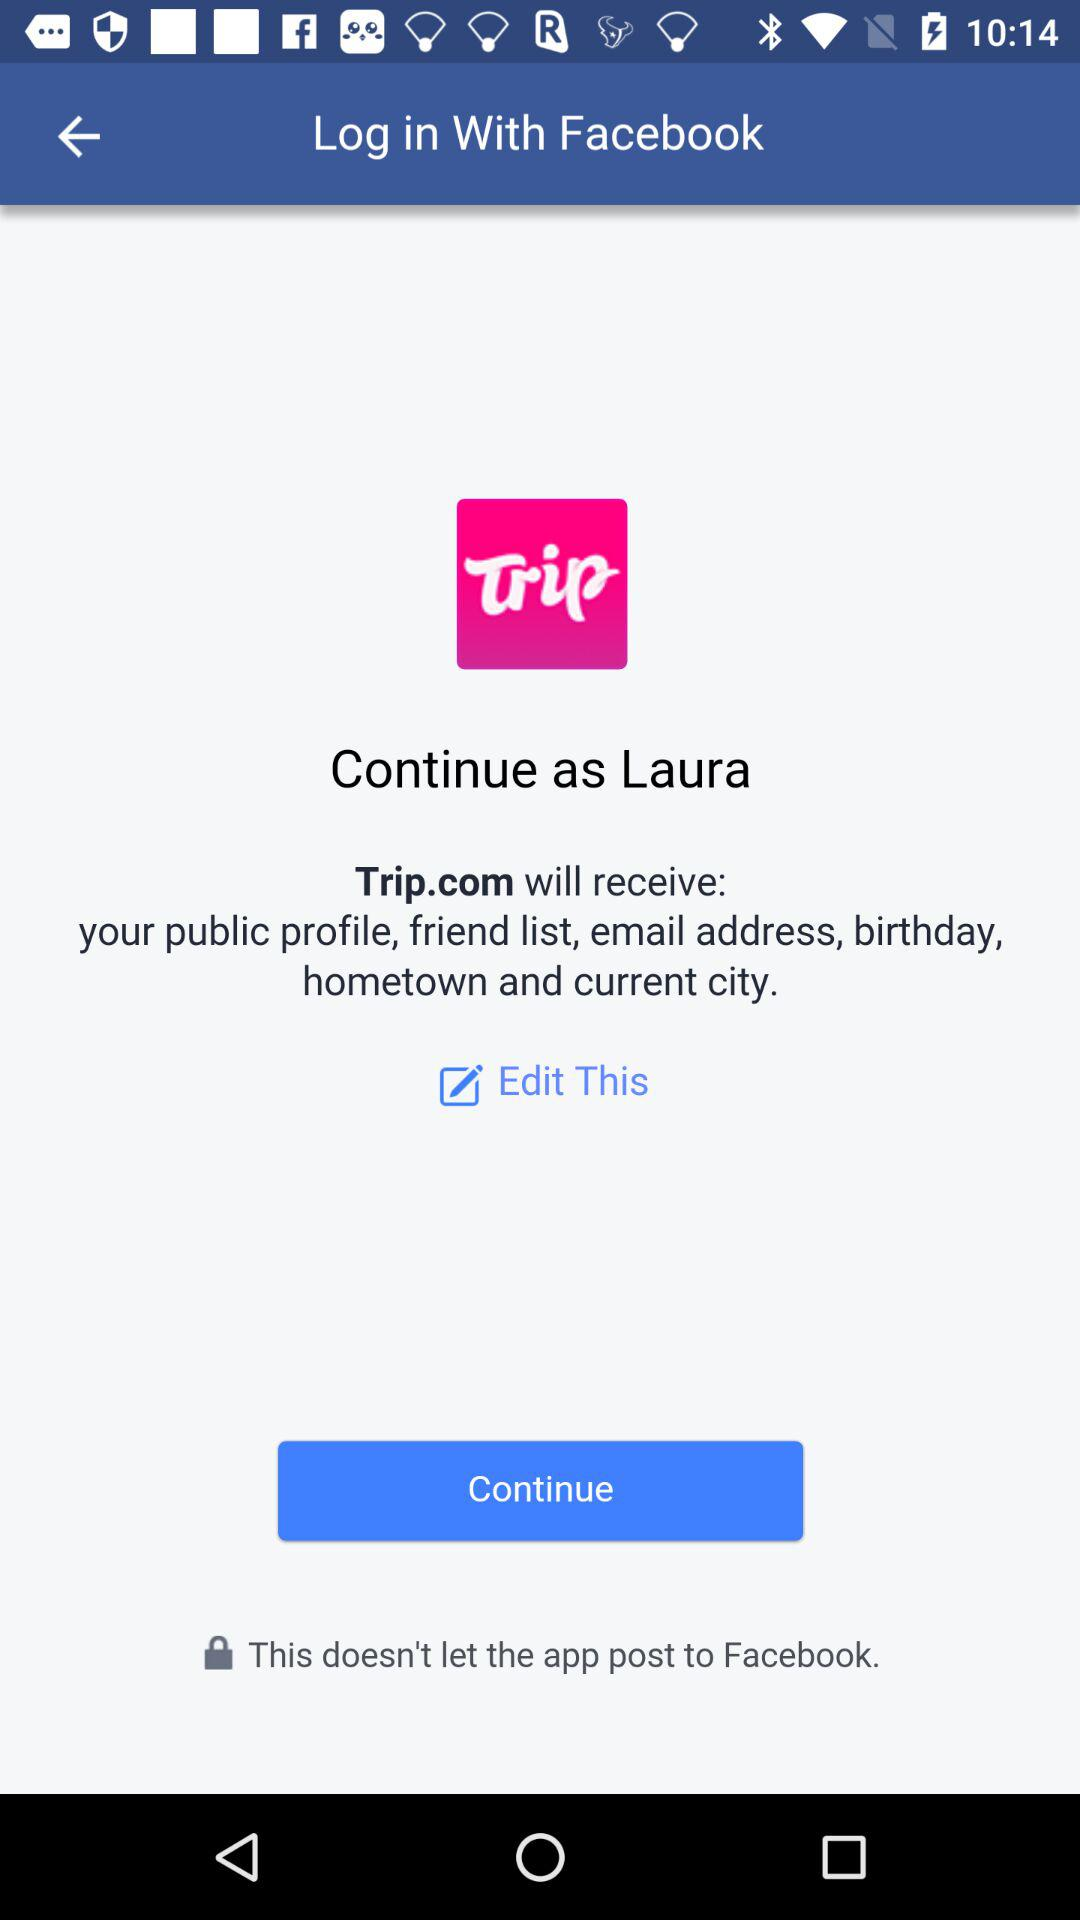What is the user name? The user name is Laura. 